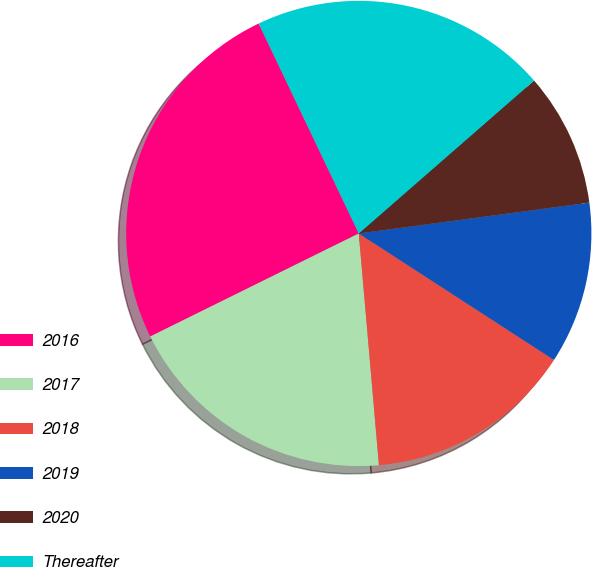Convert chart. <chart><loc_0><loc_0><loc_500><loc_500><pie_chart><fcel>2016<fcel>2017<fcel>2018<fcel>2019<fcel>2020<fcel>Thereafter<nl><fcel>25.22%<fcel>19.08%<fcel>14.47%<fcel>11.27%<fcel>9.3%<fcel>20.67%<nl></chart> 